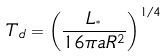<formula> <loc_0><loc_0><loc_500><loc_500>T _ { d } = \left ( \frac { L _ { ^ { * } } } { 1 6 \pi a R ^ { 2 } } \right ) ^ { 1 / 4 }</formula> 